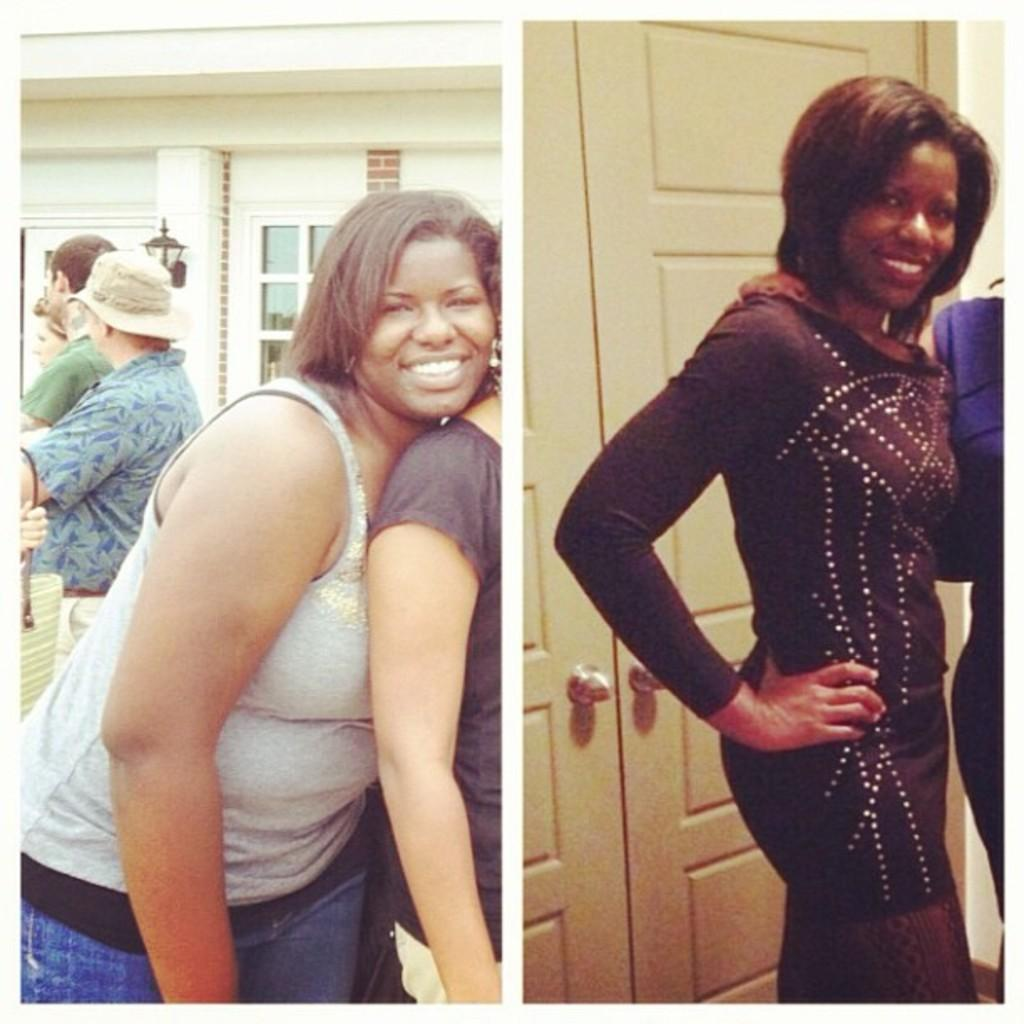What can be seen on the left side of the image? There are persons, a wall, windows, a light, and objects on the left side of the image. What is the woman doing on the right side of the image? The provided facts do not specify what the woman is doing on the right side of the image. What architectural features are present on the right side of the image? There are doors and a wall on the right side of the image. What type of pollution is visible in the image? There is no mention of pollution in the image. Can you describe the dog that is sitting next to the woman on the right side of the image? There is no dog present in the image. 